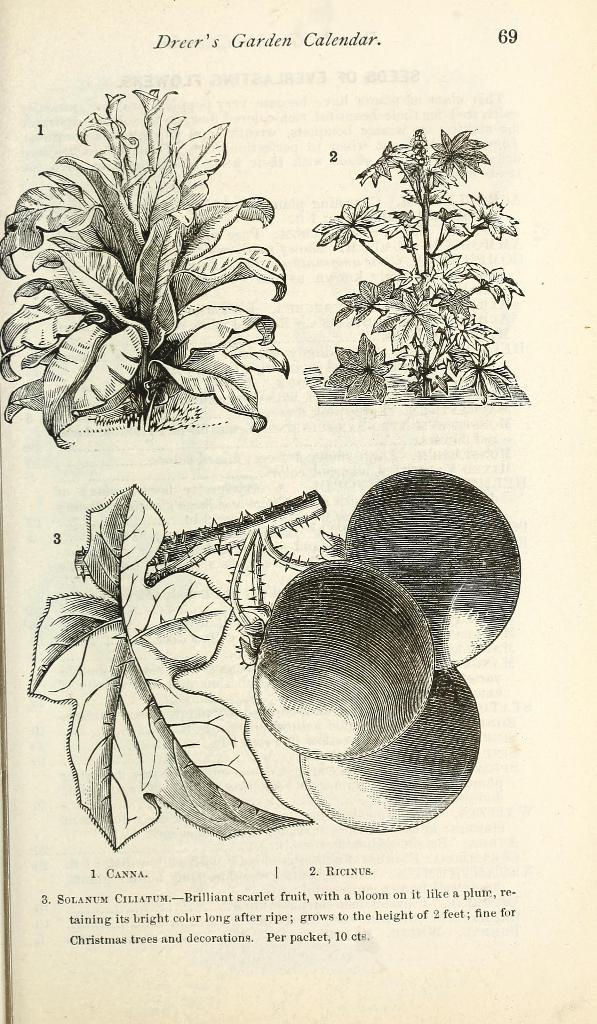What is the main subject of the image? The main subject of the image is a paper. What can be found on the paper? There is writing on the paper. What type of artwork is present on the paper? There are black and white paintings of plants and vegetables in the image. What type of pan is visible in the image? There is no pan present in the image. How many friends are depicted in the image? There are no people, including friends, depicted in the image. 